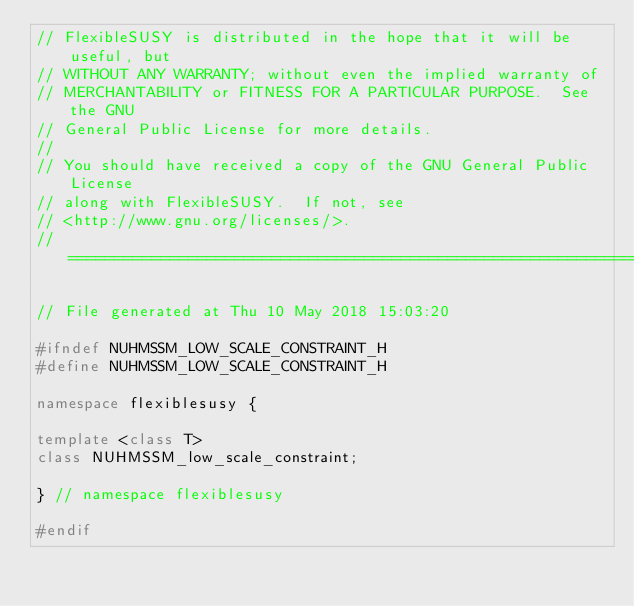Convert code to text. <code><loc_0><loc_0><loc_500><loc_500><_C++_>// FlexibleSUSY is distributed in the hope that it will be useful, but
// WITHOUT ANY WARRANTY; without even the implied warranty of
// MERCHANTABILITY or FITNESS FOR A PARTICULAR PURPOSE.  See the GNU
// General Public License for more details.
//
// You should have received a copy of the GNU General Public License
// along with FlexibleSUSY.  If not, see
// <http://www.gnu.org/licenses/>.
// ====================================================================

// File generated at Thu 10 May 2018 15:03:20

#ifndef NUHMSSM_LOW_SCALE_CONSTRAINT_H
#define NUHMSSM_LOW_SCALE_CONSTRAINT_H

namespace flexiblesusy {

template <class T>
class NUHMSSM_low_scale_constraint;

} // namespace flexiblesusy

#endif
</code> 